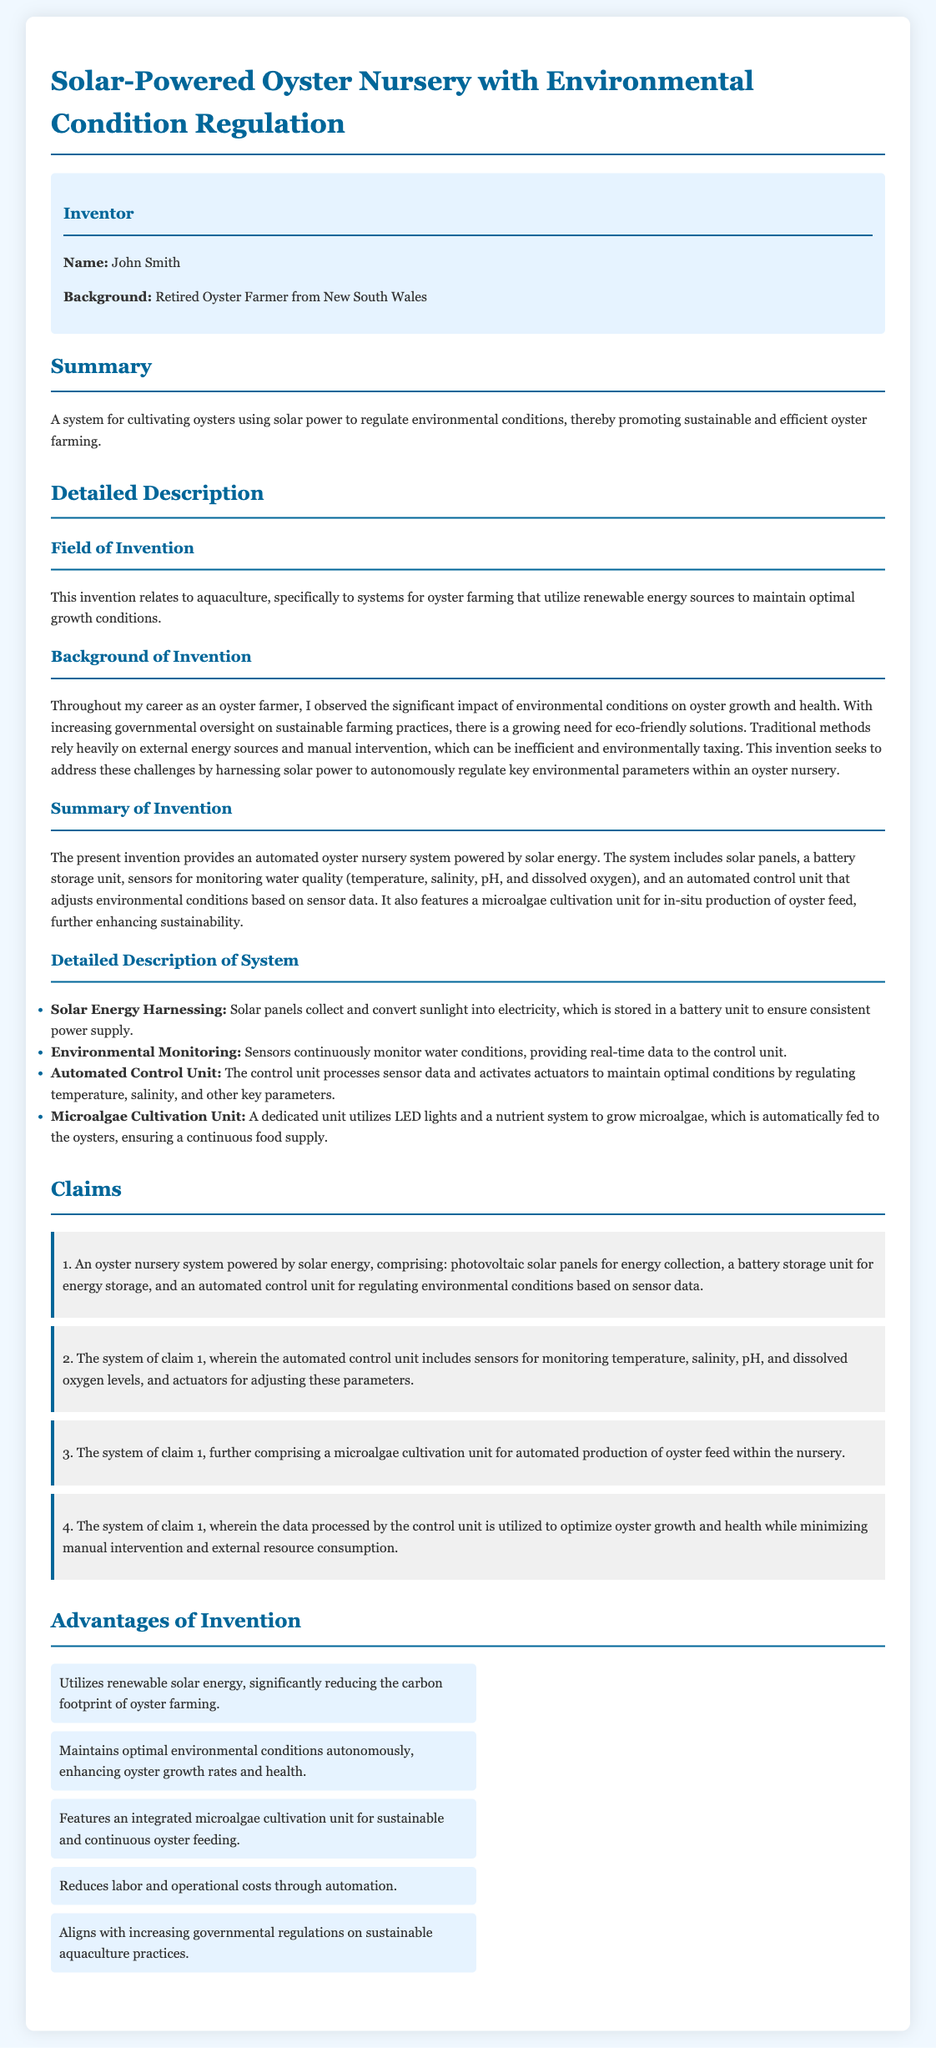what is the name of the inventor? The inventor's name is stated in the inventor information section of the document.
Answer: John Smith what is the background of the inventor? The background of the inventor is mentioned in the inventor information section.
Answer: Retired Oyster Farmer from New South Wales what energy source does the system use? The summary of the invention indicates the energy source utilized in the oyster nursery system.
Answer: Solar power which environmental parameters are monitored by sensors? The detailed description lists the specific environmental parameters monitored by the sensors.
Answer: Temperature, salinity, pH, and dissolved oxygen what is included in the microalgae cultivation unit? The detailed description of the system specifies what is utilized in the microalgae cultivation unit.
Answer: LED lights and a nutrient system how many claims are presented in the document? The claims section outlines the specific claims made in the patent application.
Answer: Four claims what is one advantage of using this invention? The advantages section highlights the benefits of the solar-powered oyster nursery system.
Answer: Utilizes renewable solar energy how does the automated control unit benefit oyster farming? The claims section describes the optimization goal of the automated control unit for oysters.
Answer: Optimize oyster growth and health while minimizing manual intervention what does the invention align with regarding regulations? The advantages section mentions the alignment of the invention with external factors.
Answer: Increasing governmental regulations on sustainable aquaculture practices 